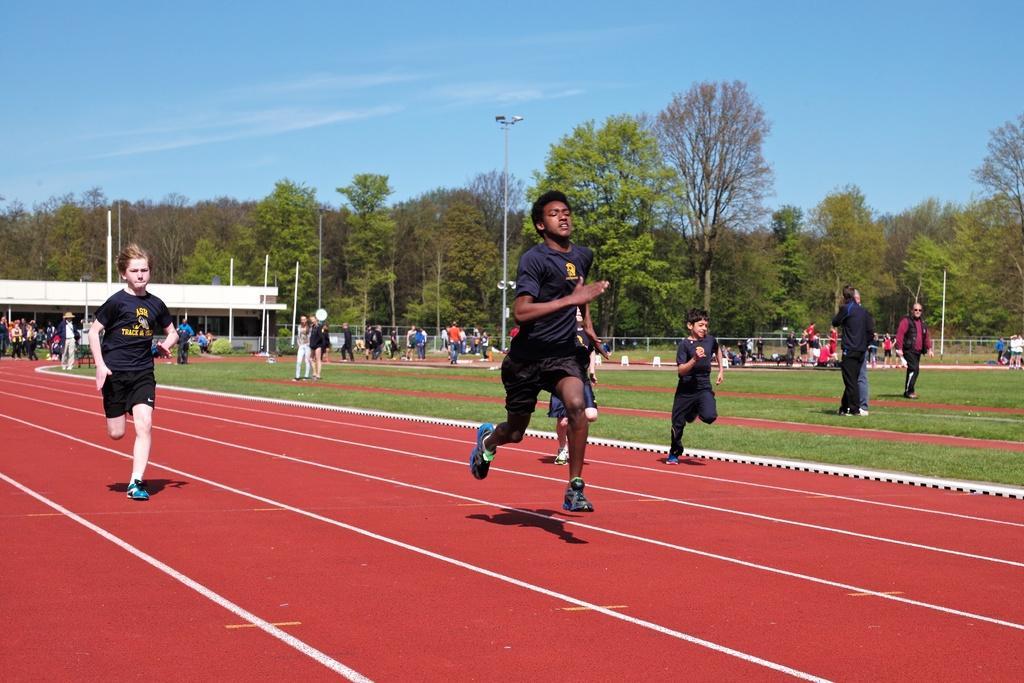How would you summarize this image in a sentence or two? In this image I can see a ground and on the left side I can see a red color carpet visible on the ground and I can see there are few boys running on the carpet and in the middle I can see few persons walking and standing on the ground and at the top I can see the sky and street light pole and tent. 